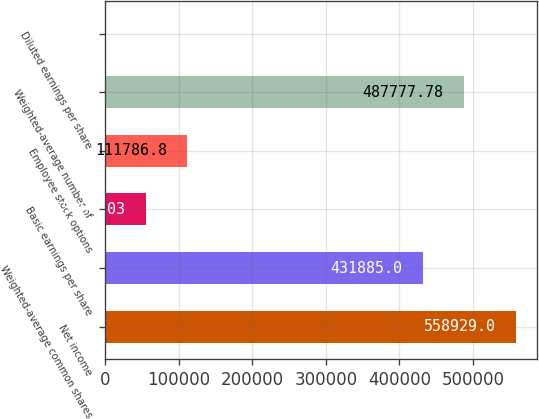Convert chart to OTSL. <chart><loc_0><loc_0><loc_500><loc_500><bar_chart><fcel>Net income<fcel>Weighted-average common shares<fcel>Basic earnings per share<fcel>Employee stock options<fcel>Weighted-average number of<fcel>Diluted earnings per share<nl><fcel>558929<fcel>431885<fcel>55894<fcel>111787<fcel>487778<fcel>1.25<nl></chart> 